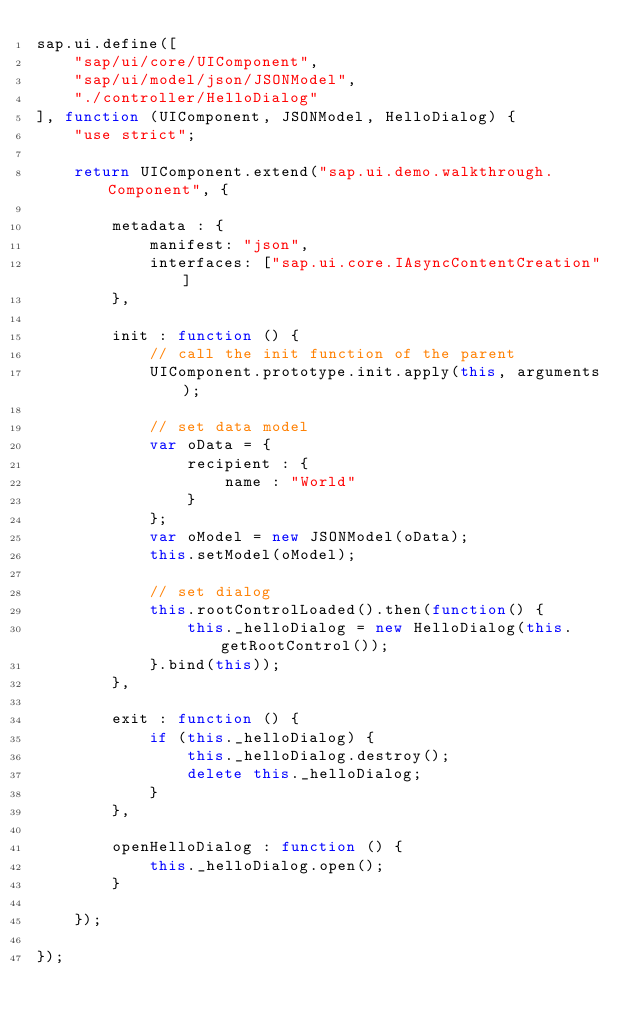<code> <loc_0><loc_0><loc_500><loc_500><_JavaScript_>sap.ui.define([
	"sap/ui/core/UIComponent",
	"sap/ui/model/json/JSONModel",
	"./controller/HelloDialog"
], function (UIComponent, JSONModel, HelloDialog) {
	"use strict";

	return UIComponent.extend("sap.ui.demo.walkthrough.Component", {

		metadata : {
			manifest: "json",
			interfaces: ["sap.ui.core.IAsyncContentCreation"]
		},

		init : function () {
			// call the init function of the parent
			UIComponent.prototype.init.apply(this, arguments);

			// set data model
			var oData = {
				recipient : {
					name : "World"
				}
			};
			var oModel = new JSONModel(oData);
			this.setModel(oModel);

			// set dialog
			this.rootControlLoaded().then(function() {
				this._helloDialog = new HelloDialog(this.getRootControl());
			}.bind(this));
		},

		exit : function () {
			if (this._helloDialog) {
				this._helloDialog.destroy();
				delete this._helloDialog;
			}
		},

		openHelloDialog : function () {
			this._helloDialog.open();
		}

	});

});</code> 